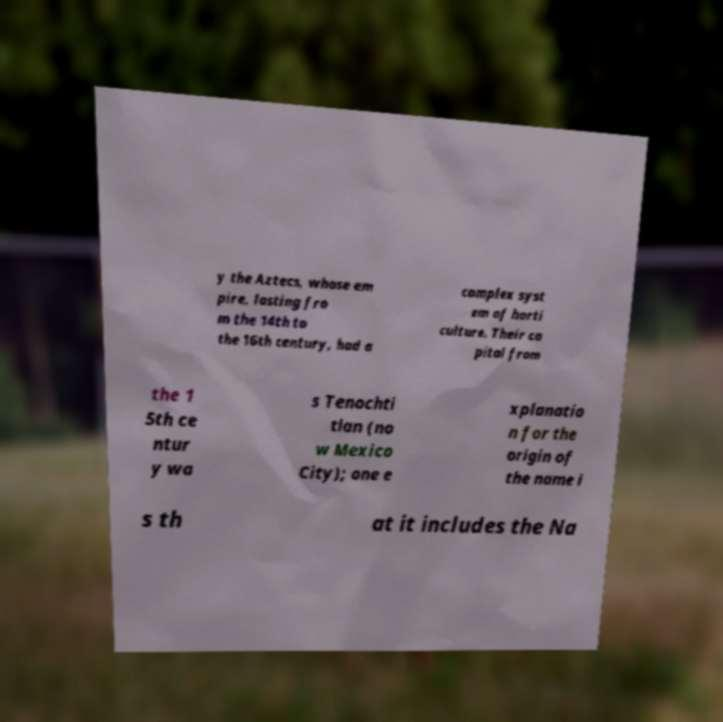Can you accurately transcribe the text from the provided image for me? y the Aztecs, whose em pire, lasting fro m the 14th to the 16th century, had a complex syst em of horti culture. Their ca pital from the 1 5th ce ntur y wa s Tenochti tlan (no w Mexico City); one e xplanatio n for the origin of the name i s th at it includes the Na 